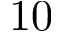<formula> <loc_0><loc_0><loc_500><loc_500>1 0</formula> 